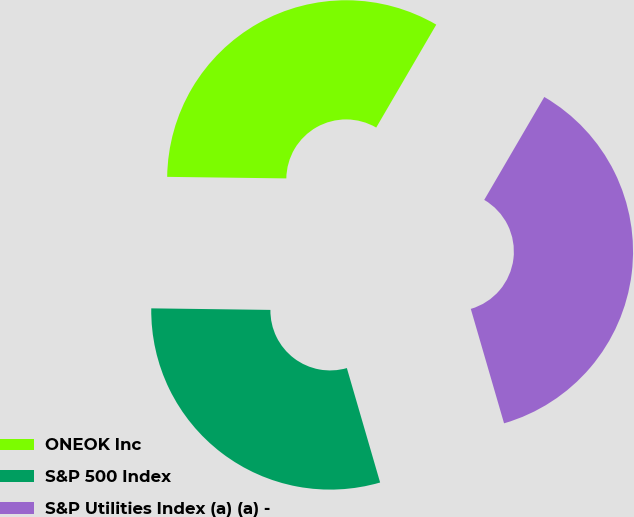Convert chart to OTSL. <chart><loc_0><loc_0><loc_500><loc_500><pie_chart><fcel>ONEOK Inc<fcel>S&P 500 Index<fcel>S&P Utilities Index (a) (a) -<nl><fcel>33.2%<fcel>29.71%<fcel>37.09%<nl></chart> 